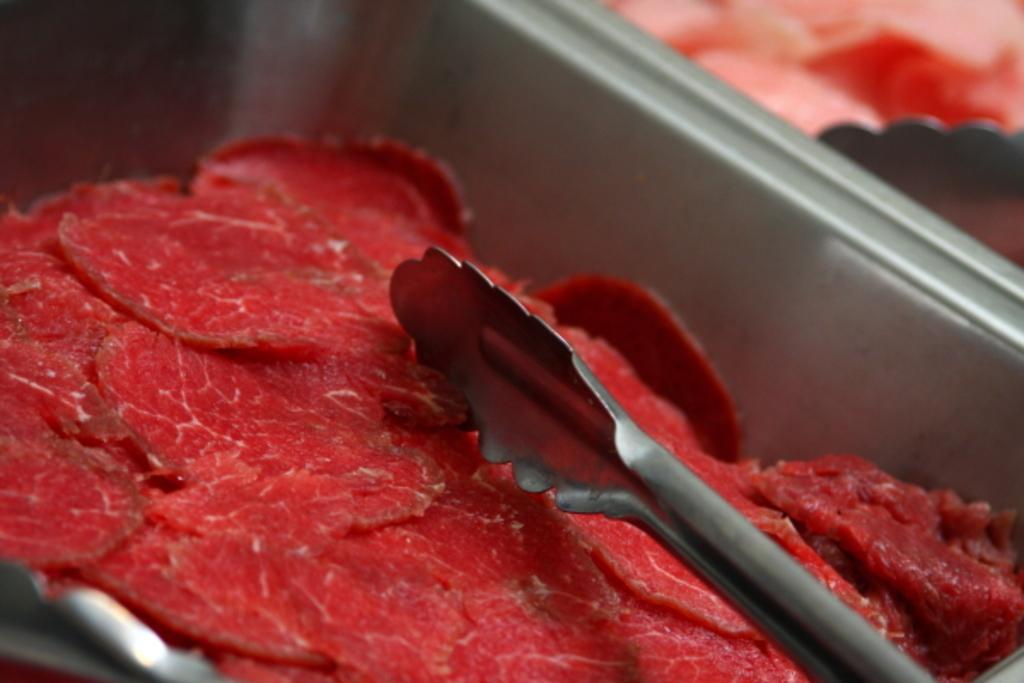In one or two sentences, can you explain what this image depicts? In this image there is an iron tray which has red meat in it. Above the meat there is a tong. 